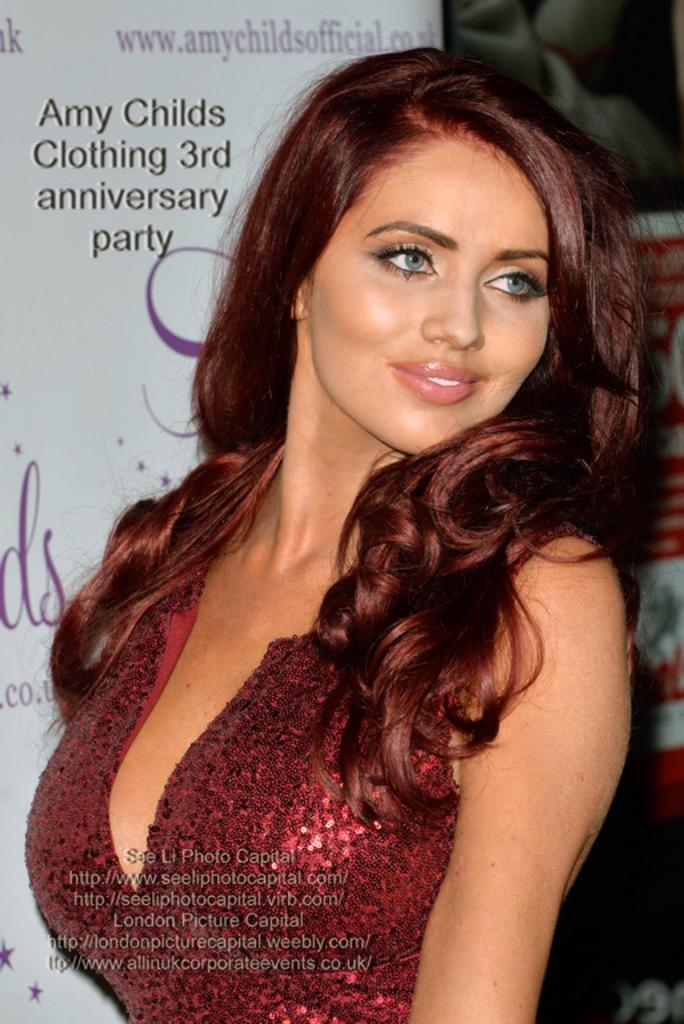What is the main subject of the image? There is a person standing in the image. What is the person wearing? The person is wearing a red dress. What can be seen in the background of the image? There is a white color banner in the background. What is written on the banner? There is writing on the banner. How many screws are visible on the person's red dress in the image? There are no screws visible on the person's red dress in the image. What type of lizards can be seen crawling on the banner in the image? There are no lizards present in the image; it only features a person, a red dress, and a banner with writing. 